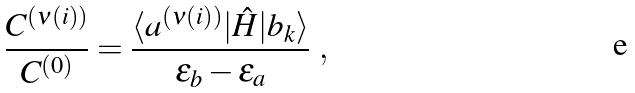<formula> <loc_0><loc_0><loc_500><loc_500>\frac { C ^ { ( \nu ( i ) ) } } { C ^ { ( 0 ) } } = \frac { \langle a ^ { ( \nu ( i ) ) } | \hat { H } | b _ { k } \rangle } { \varepsilon _ { b } - \varepsilon _ { a } } \ ,</formula> 